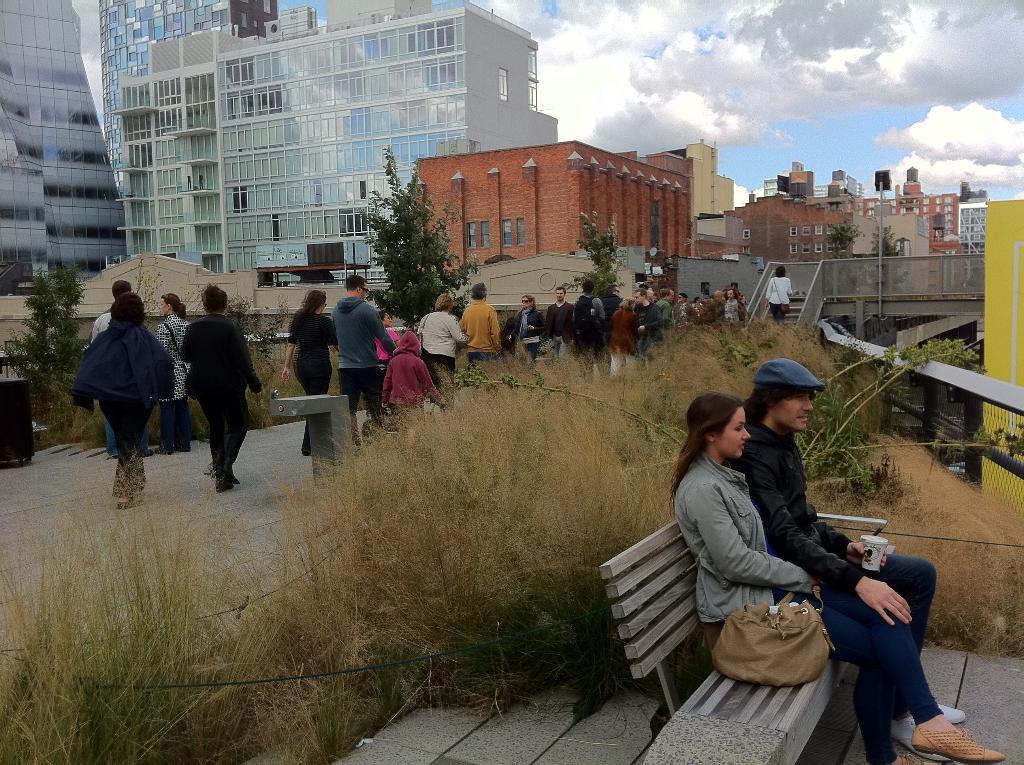Could you give a brief overview of what you see in this image? This is a picture taken outside a city on the streets. In the foreground there are shrubs, bench, on the bench there are two people sitting. In the center of the picture there are people walking down the road. On the right there is a bridge and staircase. In the center of the picture there are plants and shrubs. In the background there are buildings. Sky is cloudy. 